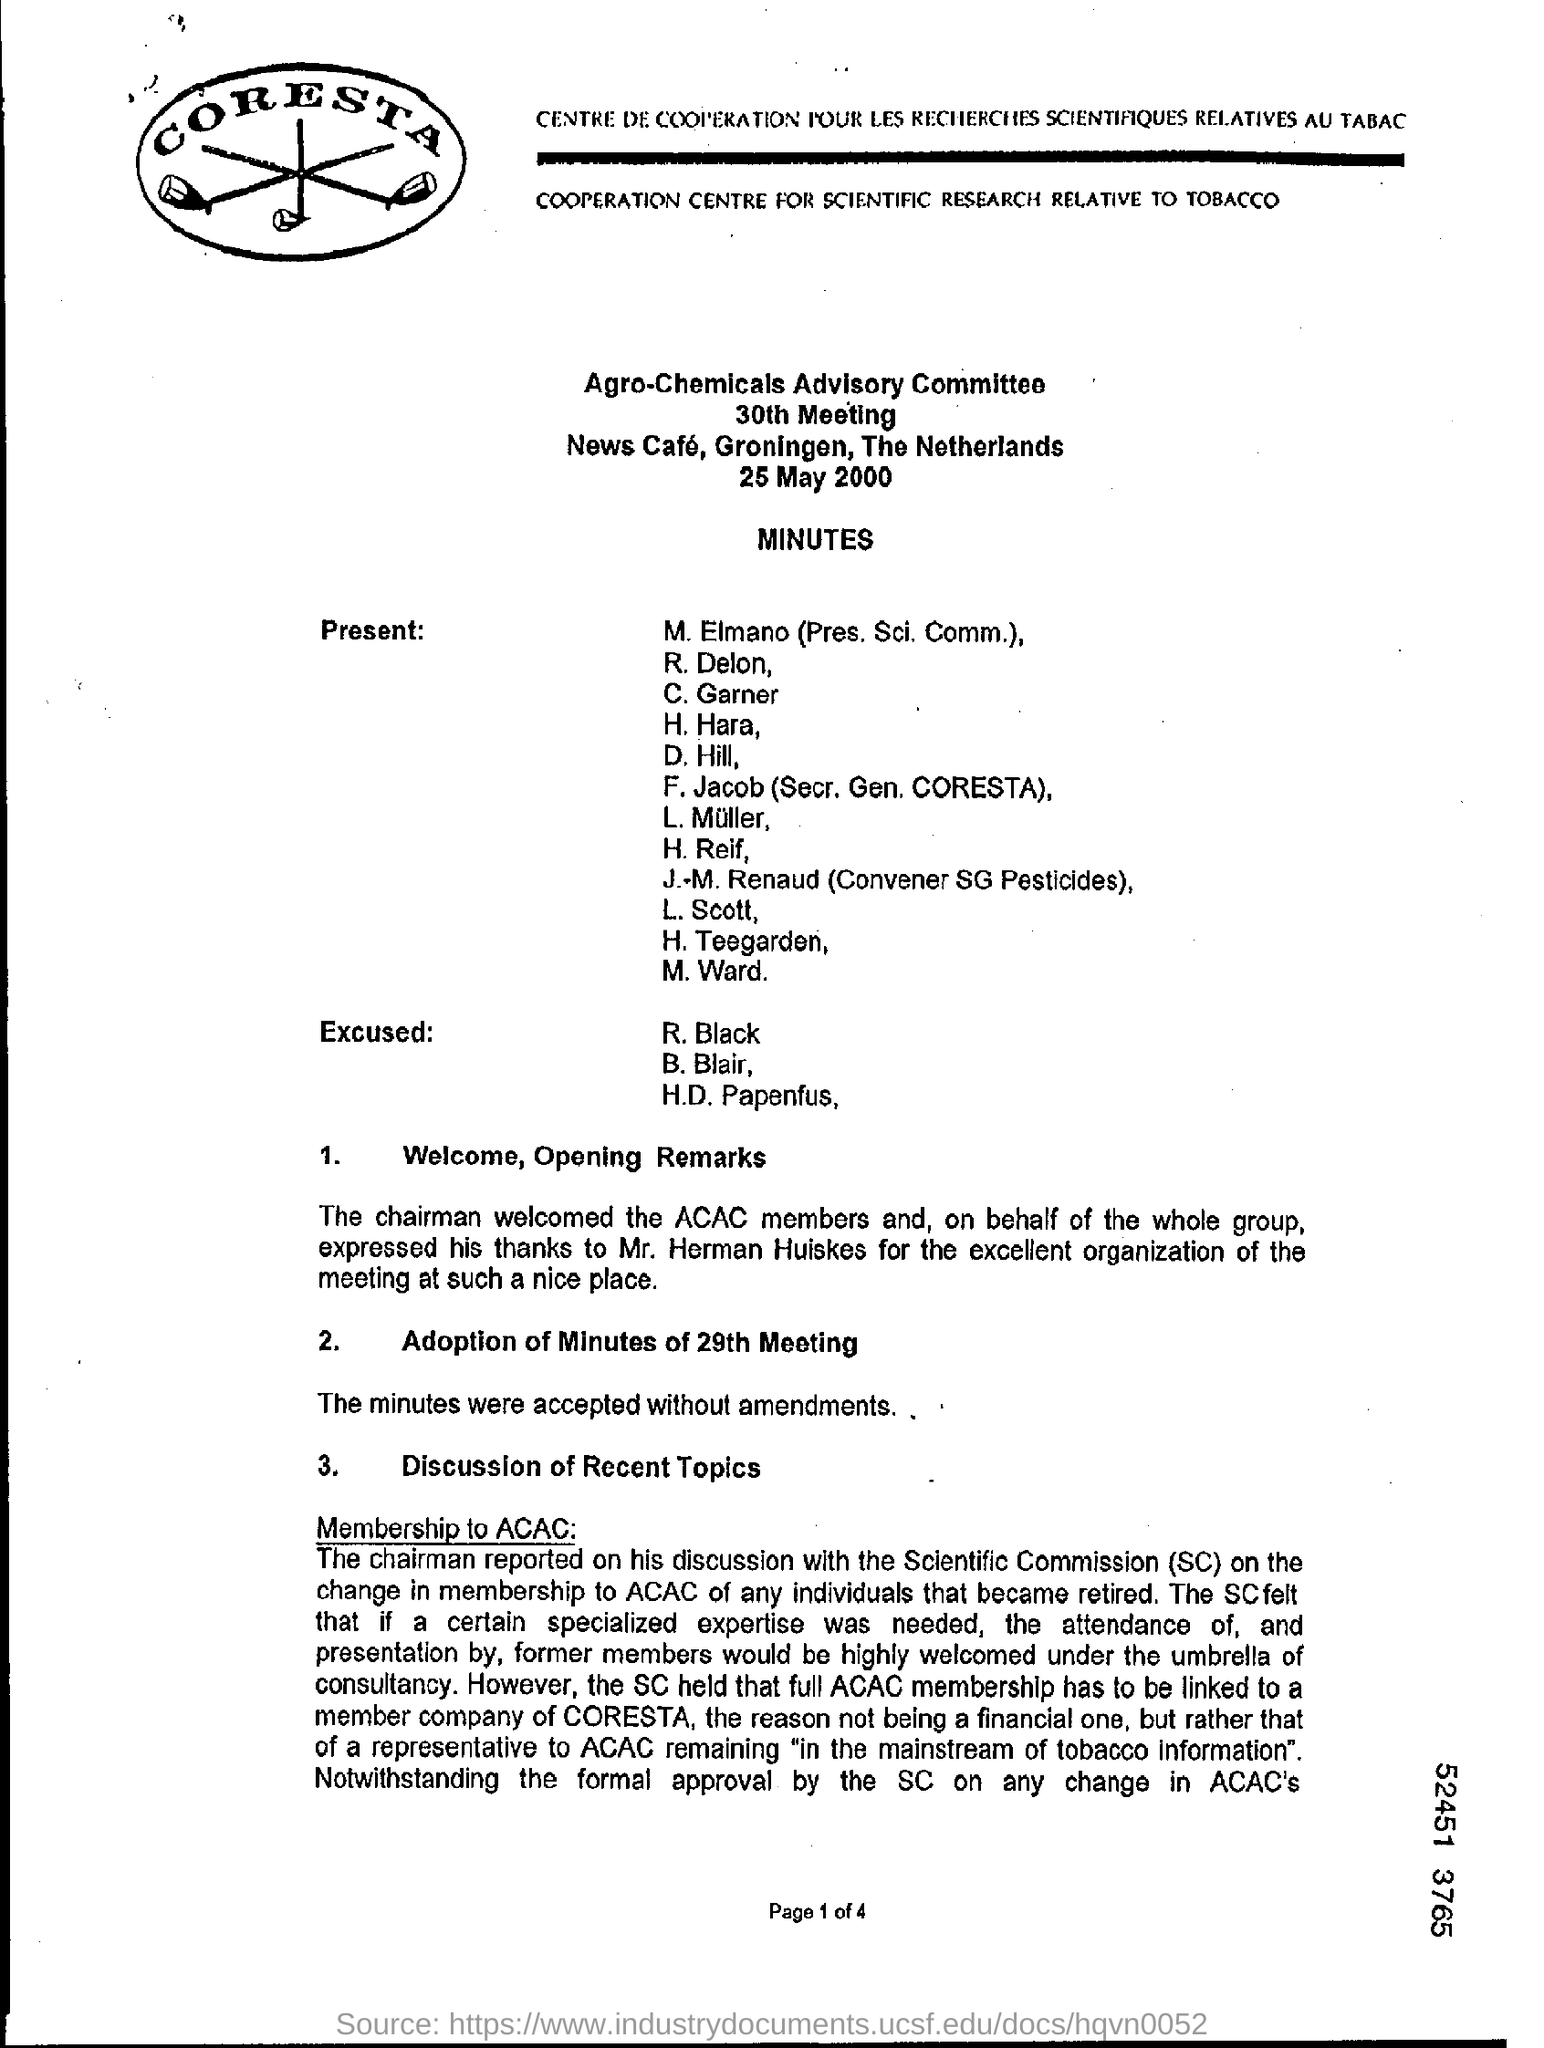What is the position of j. m. renaud  ?
Keep it short and to the point. Convener SG pesticides. 